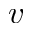Convert formula to latex. <formula><loc_0><loc_0><loc_500><loc_500>v</formula> 